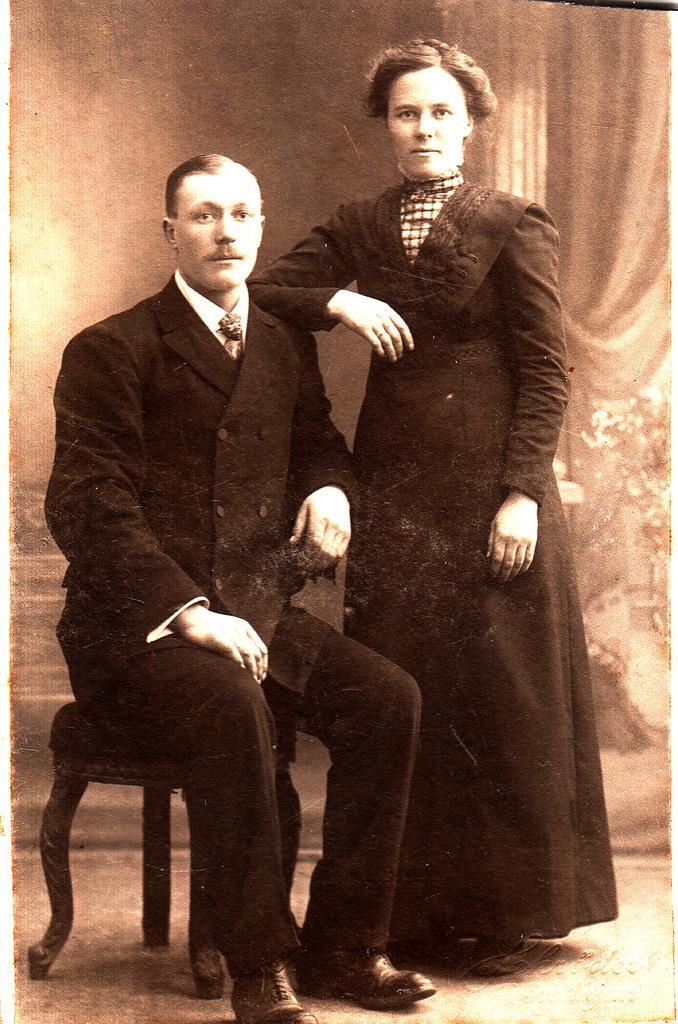In one or two sentences, can you explain what this image depicts? In this image I can see a man sitting on the table beside him there is a lady standing. 